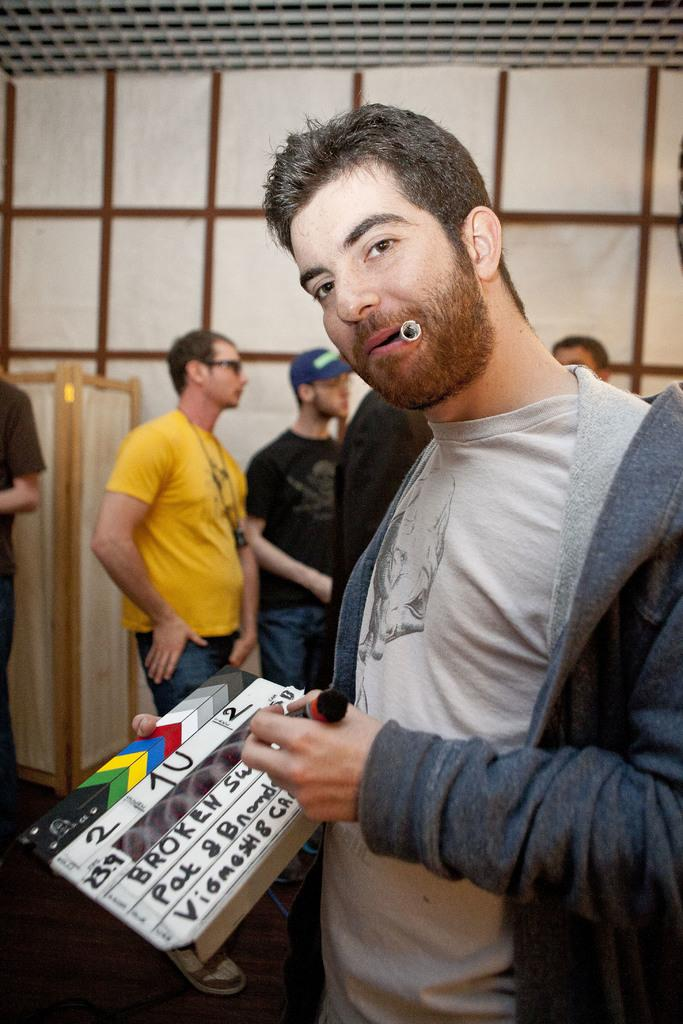What is the main subject of the image? The main subject of the image is a group of people. Can you describe the man on the right side of the image? The man on the right side of the image is holding a pen and a board. What is the man doing with the pen and board? The man is likely writing or drawing on the board with the pen. What is in the man's mouth? There is a cap in the man's mouth. What type of vase can be seen in the image? There is no vase present in the image. What religious event is taking place in the image? There is no indication of a religious event or a church in the image. 